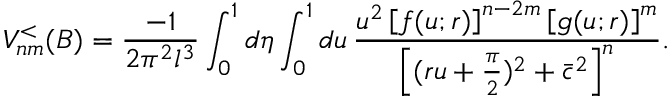Convert formula to latex. <formula><loc_0><loc_0><loc_500><loc_500>V _ { n m } ^ { < } ( B ) = \frac { - 1 } { 2 \pi ^ { 2 } l ^ { 3 } } \int _ { 0 } ^ { 1 } d \eta \int _ { 0 } ^ { 1 } d u \, \frac { u ^ { 2 } \left [ f ( u ; r ) \right ] ^ { n - 2 m } \left [ g ( u ; r ) \right ] ^ { m } } { \left [ ( r u + \frac { \pi } { 2 } ) ^ { 2 } + \bar { c } ^ { 2 } \right ] ^ { n } } .</formula> 